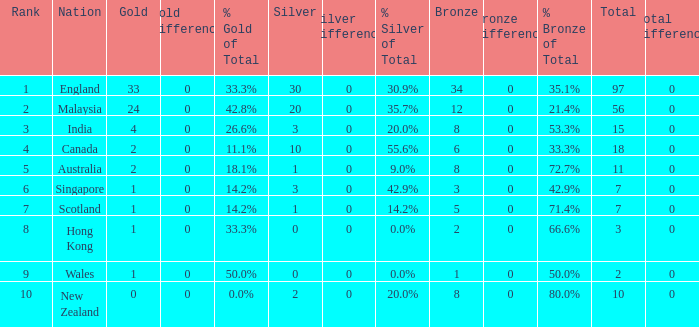Parse the table in full. {'header': ['Rank', 'Nation', 'Gold', 'Gold Difference', '% Gold of Total', 'Silver', 'Silver Difference', '% Silver of Total', 'Bronze', 'Bronze Difference', '% Bronze of Total', 'Total', 'Total Difference'], 'rows': [['1', 'England', '33', '0', '33.3%', '30', '0', '30.9%', '34', '0', '35.1%', '97', '0'], ['2', 'Malaysia', '24', '0', '42.8%', '20', '0', '35.7%', '12', '0', '21.4%', '56', '0'], ['3', 'India', '4', '0', '26.6%', '3', '0', '20.0%', '8', '0', '53.3%', '15', '0'], ['4', 'Canada', '2', '0', '11.1%', '10', '0', '55.6%', '6', '0', '33.3%', '18', '0'], ['5', 'Australia', '2', '0', '18.1%', '1', '0', '9.0%', '8', '0', '72.7%', '11', '0'], ['6', 'Singapore', '1', '0', '14.2%', '3', '0', '42.9%', '3', '0', '42.9%', '7', '0'], ['7', 'Scotland', '1', '0', '14.2%', '1', '0', '14.2%', '5', '0', '71.4%', '7', '0'], ['8', 'Hong Kong', '1', '0', '33.3%', '0', '0', '0.0%', '2', '0', '66.6%', '3', '0'], ['9', 'Wales', '1', '0', '50.0%', '0', '0', '0.0%', '1', '0', '50.0%', '2', '0'], ['10', 'New Zealand', '0', '0', '0.0%', '2', '0', '20.0%', '8', '0', '80.0%', '10', '0']]} What is the number of bronze that Scotland, which has less than 7 total medals, has? None. 